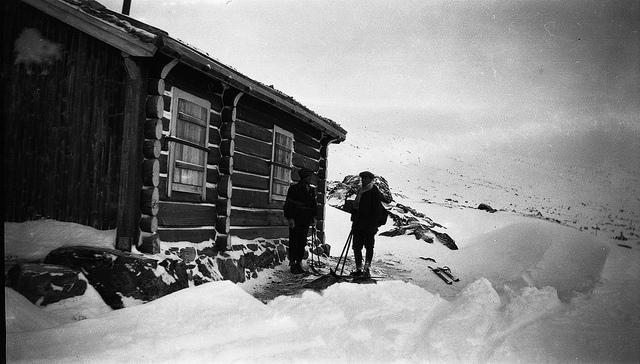How many people are visible?
Give a very brief answer. 2. 